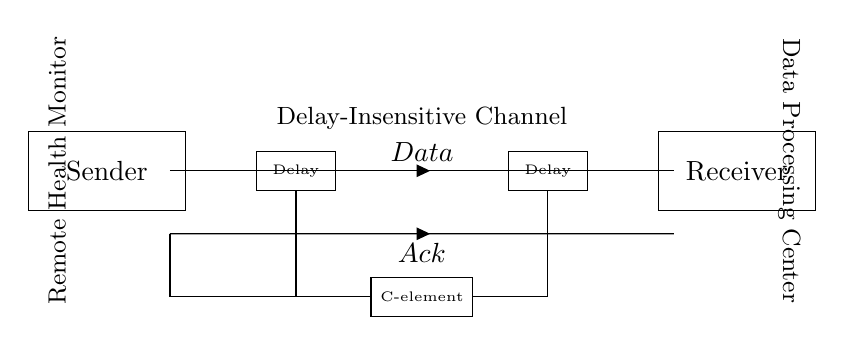What are the main components of this circuit? The circuit contains a Sender, a Receiver, two Delay elements, and a C-element. Each component plays a specific role in the data transmission process.
Answer: Sender, Receiver, Delay, C-element What does the data transmission line represent? The line labeled 'Data' indicates the pathway through which information is sent from the Sender to the Receiver. It shows the flow of data in the system.
Answer: Data How many delay elements are present? There are two Delay components in the circuit, which help to manage timing in the asynchronous data transfer.
Answer: Two What is the function of the C-element in this circuit? The C-element is responsible for coordinating the signals from the Delay elements. It determines when to send the acknowledgment based on input conditions, ensuring synchronization.
Answer: Coordination Where is the acknowledgment line directed? The acknowledgment line (labeled 'Ack') is directed from the C-element towards the Sender, indicating a response after receiving data.
Answer: Sender How does asynchronous transmission differ from synchronous in this context? Asynchronous transmission does not require a shared clock signal; instead, the timing is managed by delay elements and the C-element to accommodate variable transmission times.
Answer: No shared clock 